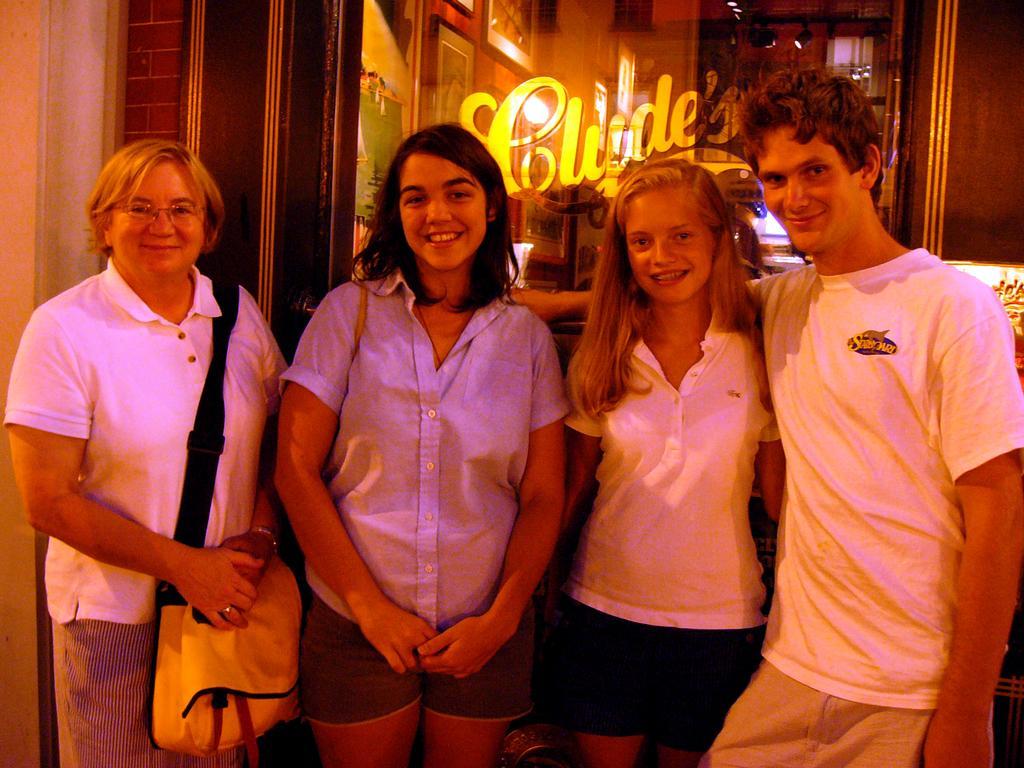Describe this image in one or two sentences. In this picture there are three women and man. All of them are wearing white T shirts. Women towards the left, she is carrying a bag. In the background there is a wall with a glass. Through the glass we can see the frame, lights etc. On the glass there is some text. 